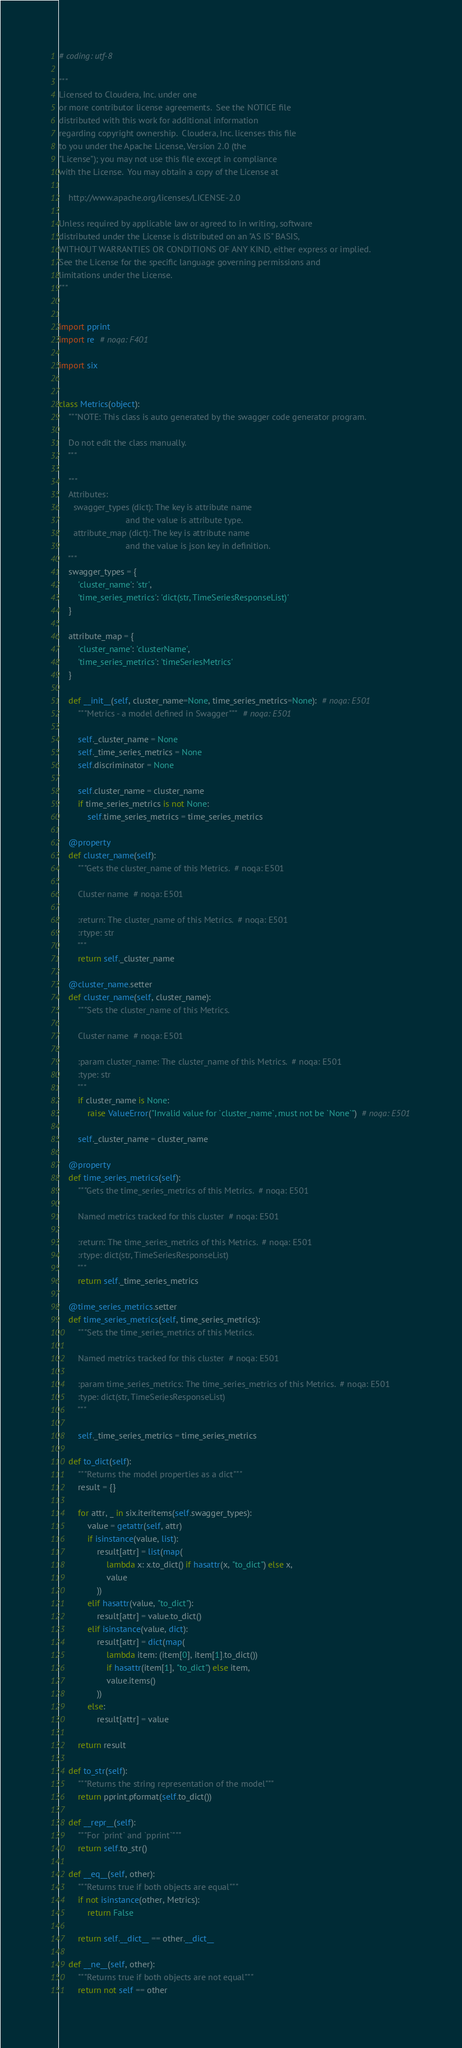<code> <loc_0><loc_0><loc_500><loc_500><_Python_># coding: utf-8

"""
Licensed to Cloudera, Inc. under one
or more contributor license agreements.  See the NOTICE file
distributed with this work for additional information
regarding copyright ownership.  Cloudera, Inc. licenses this file
to you under the Apache License, Version 2.0 (the
"License"); you may not use this file except in compliance
with the License.  You may obtain a copy of the License at

    http://www.apache.org/licenses/LICENSE-2.0

Unless required by applicable law or agreed to in writing, software
distributed under the License is distributed on an "AS IS" BASIS,
WITHOUT WARRANTIES OR CONDITIONS OF ANY KIND, either express or implied.
See the License for the specific language governing permissions and
limitations under the License.
"""


import pprint
import re  # noqa: F401

import six


class Metrics(object):
    """NOTE: This class is auto generated by the swagger code generator program.

    Do not edit the class manually.
    """

    """
    Attributes:
      swagger_types (dict): The key is attribute name
                            and the value is attribute type.
      attribute_map (dict): The key is attribute name
                            and the value is json key in definition.
    """
    swagger_types = {
        'cluster_name': 'str',
        'time_series_metrics': 'dict(str, TimeSeriesResponseList)'
    }

    attribute_map = {
        'cluster_name': 'clusterName',
        'time_series_metrics': 'timeSeriesMetrics'
    }

    def __init__(self, cluster_name=None, time_series_metrics=None):  # noqa: E501
        """Metrics - a model defined in Swagger"""  # noqa: E501

        self._cluster_name = None
        self._time_series_metrics = None
        self.discriminator = None

        self.cluster_name = cluster_name
        if time_series_metrics is not None:
            self.time_series_metrics = time_series_metrics

    @property
    def cluster_name(self):
        """Gets the cluster_name of this Metrics.  # noqa: E501

        Cluster name  # noqa: E501

        :return: The cluster_name of this Metrics.  # noqa: E501
        :rtype: str
        """
        return self._cluster_name

    @cluster_name.setter
    def cluster_name(self, cluster_name):
        """Sets the cluster_name of this Metrics.

        Cluster name  # noqa: E501

        :param cluster_name: The cluster_name of this Metrics.  # noqa: E501
        :type: str
        """
        if cluster_name is None:
            raise ValueError("Invalid value for `cluster_name`, must not be `None`")  # noqa: E501

        self._cluster_name = cluster_name

    @property
    def time_series_metrics(self):
        """Gets the time_series_metrics of this Metrics.  # noqa: E501

        Named metrics tracked for this cluster  # noqa: E501

        :return: The time_series_metrics of this Metrics.  # noqa: E501
        :rtype: dict(str, TimeSeriesResponseList)
        """
        return self._time_series_metrics

    @time_series_metrics.setter
    def time_series_metrics(self, time_series_metrics):
        """Sets the time_series_metrics of this Metrics.

        Named metrics tracked for this cluster  # noqa: E501

        :param time_series_metrics: The time_series_metrics of this Metrics.  # noqa: E501
        :type: dict(str, TimeSeriesResponseList)
        """

        self._time_series_metrics = time_series_metrics

    def to_dict(self):
        """Returns the model properties as a dict"""
        result = {}

        for attr, _ in six.iteritems(self.swagger_types):
            value = getattr(self, attr)
            if isinstance(value, list):
                result[attr] = list(map(
                    lambda x: x.to_dict() if hasattr(x, "to_dict") else x,
                    value
                ))
            elif hasattr(value, "to_dict"):
                result[attr] = value.to_dict()
            elif isinstance(value, dict):
                result[attr] = dict(map(
                    lambda item: (item[0], item[1].to_dict())
                    if hasattr(item[1], "to_dict") else item,
                    value.items()
                ))
            else:
                result[attr] = value

        return result

    def to_str(self):
        """Returns the string representation of the model"""
        return pprint.pformat(self.to_dict())

    def __repr__(self):
        """For `print` and `pprint`"""
        return self.to_str()

    def __eq__(self, other):
        """Returns true if both objects are equal"""
        if not isinstance(other, Metrics):
            return False

        return self.__dict__ == other.__dict__

    def __ne__(self, other):
        """Returns true if both objects are not equal"""
        return not self == other
</code> 